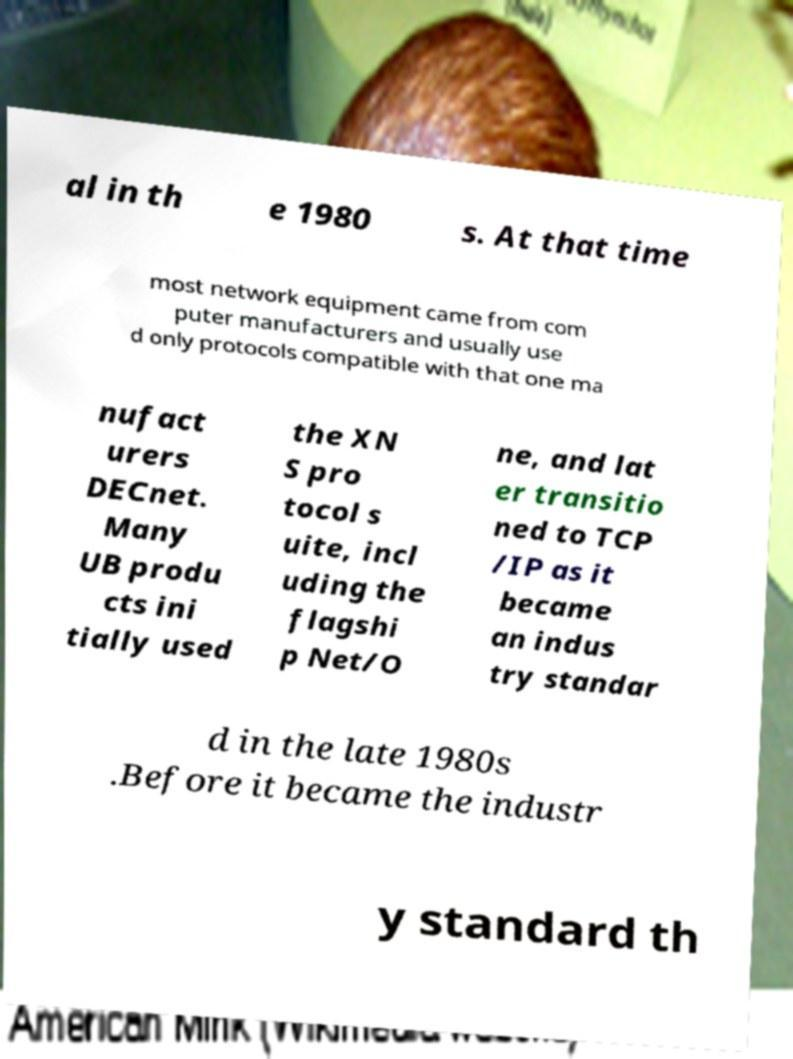There's text embedded in this image that I need extracted. Can you transcribe it verbatim? al in th e 1980 s. At that time most network equipment came from com puter manufacturers and usually use d only protocols compatible with that one ma nufact urers DECnet. Many UB produ cts ini tially used the XN S pro tocol s uite, incl uding the flagshi p Net/O ne, and lat er transitio ned to TCP /IP as it became an indus try standar d in the late 1980s .Before it became the industr y standard th 